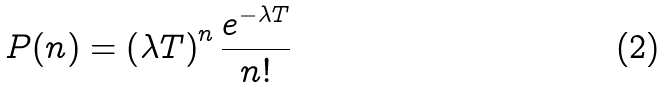<formula> <loc_0><loc_0><loc_500><loc_500>P ( n ) = \left ( \lambda T \right ) ^ { n } \frac { e ^ { - \lambda T } } { n ! }</formula> 